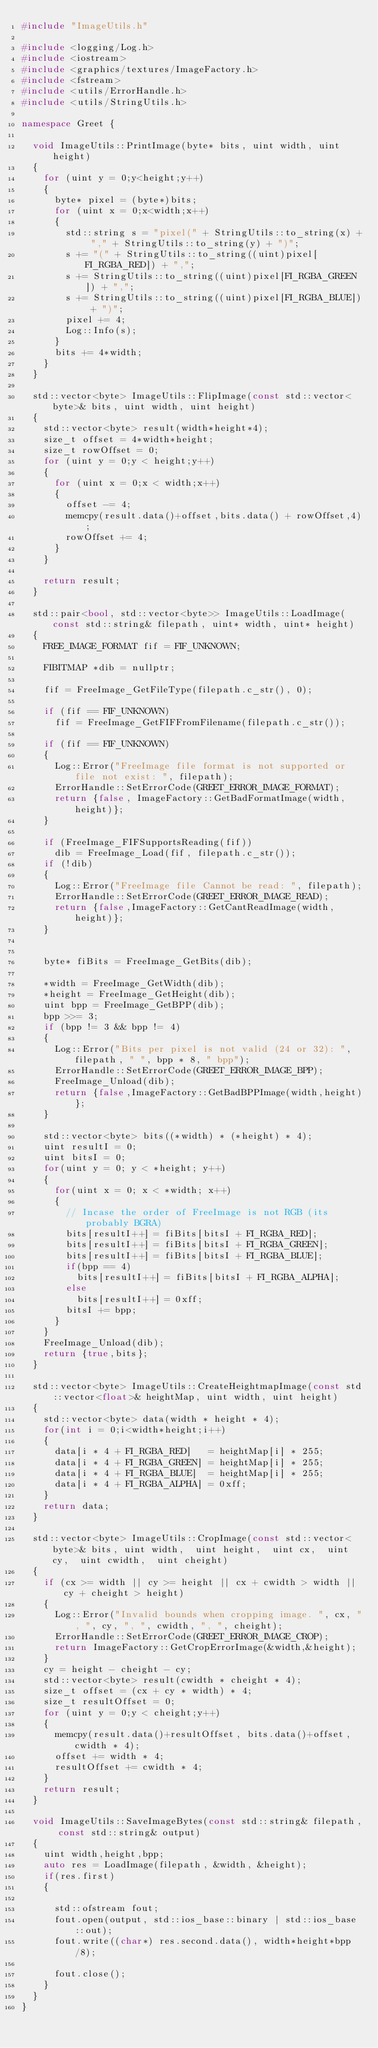<code> <loc_0><loc_0><loc_500><loc_500><_C++_>#include "ImageUtils.h"

#include <logging/Log.h>
#include <iostream>
#include <graphics/textures/ImageFactory.h>
#include <fstream>
#include <utils/ErrorHandle.h>
#include <utils/StringUtils.h>

namespace Greet {

  void ImageUtils::PrintImage(byte* bits, uint width, uint height)
  {
    for (uint y = 0;y<height;y++)
    {
      byte* pixel = (byte*)bits;
      for (uint x = 0;x<width;x++)
      {
        std::string s = "pixel(" + StringUtils::to_string(x) + "," + StringUtils::to_string(y) + ")";
        s += "(" + StringUtils::to_string((uint)pixel[FI_RGBA_RED]) + ",";
        s += StringUtils::to_string((uint)pixel[FI_RGBA_GREEN]) + ",";
        s += StringUtils::to_string((uint)pixel[FI_RGBA_BLUE]) + ")";
        pixel += 4;
        Log::Info(s);
      }
      bits += 4*width;
    }
  }

  std::vector<byte> ImageUtils::FlipImage(const std::vector<byte>& bits, uint width, uint height)
  {
    std::vector<byte> result(width*height*4);
    size_t offset = 4*width*height;
    size_t rowOffset = 0;
    for (uint y = 0;y < height;y++)
    {
      for (uint x = 0;x < width;x++)
      {
        offset -= 4;
        memcpy(result.data()+offset,bits.data() + rowOffset,4);
        rowOffset += 4;
      }
    }

    return result;
  }

  std::pair<bool, std::vector<byte>> ImageUtils::LoadImage(const std::string& filepath, uint* width, uint* height)
  {
    FREE_IMAGE_FORMAT fif = FIF_UNKNOWN;

    FIBITMAP *dib = nullptr;

    fif = FreeImage_GetFileType(filepath.c_str(), 0);

    if (fif == FIF_UNKNOWN)
      fif = FreeImage_GetFIFFromFilename(filepath.c_str());

    if (fif == FIF_UNKNOWN)
    {
      Log::Error("FreeImage file format is not supported or file not exist: ", filepath);
      ErrorHandle::SetErrorCode(GREET_ERROR_IMAGE_FORMAT);
      return {false, ImageFactory::GetBadFormatImage(width,height)};
    }

    if (FreeImage_FIFSupportsReading(fif))
      dib = FreeImage_Load(fif, filepath.c_str());
    if (!dib)
    {
      Log::Error("FreeImage file Cannot be read: ", filepath);
      ErrorHandle::SetErrorCode(GREET_ERROR_IMAGE_READ);
      return {false,ImageFactory::GetCantReadImage(width,height)};
    }


    byte* fiBits = FreeImage_GetBits(dib);

    *width = FreeImage_GetWidth(dib);
    *height = FreeImage_GetHeight(dib);
    uint bpp = FreeImage_GetBPP(dib);
    bpp >>= 3;
    if (bpp != 3 && bpp != 4)
    {
      Log::Error("Bits per pixel is not valid (24 or 32): ", filepath, " ", bpp * 8, " bpp");
      ErrorHandle::SetErrorCode(GREET_ERROR_IMAGE_BPP);
      FreeImage_Unload(dib);
      return {false,ImageFactory::GetBadBPPImage(width,height)};
    }

    std::vector<byte> bits((*width) * (*height) * 4);
    uint resultI = 0;
    uint bitsI = 0;
    for(uint y = 0; y < *height; y++)
    {
      for(uint x = 0; x < *width; x++)
      {
        // Incase the order of FreeImage is not RGB (its probably BGRA)
        bits[resultI++] = fiBits[bitsI + FI_RGBA_RED];
        bits[resultI++] = fiBits[bitsI + FI_RGBA_GREEN];
        bits[resultI++] = fiBits[bitsI + FI_RGBA_BLUE];
        if(bpp == 4)
          bits[resultI++] = fiBits[bitsI + FI_RGBA_ALPHA];
        else
          bits[resultI++] = 0xff;
        bitsI += bpp;
      }
    }
    FreeImage_Unload(dib);
    return {true,bits};
  }

  std::vector<byte> ImageUtils::CreateHeightmapImage(const std::vector<float>& heightMap, uint width, uint height)
  {
    std::vector<byte> data(width * height * 4);
    for(int i = 0;i<width*height;i++)
    {
      data[i * 4 + FI_RGBA_RED]   = heightMap[i] * 255;
      data[i * 4 + FI_RGBA_GREEN] = heightMap[i] * 255;
      data[i * 4 + FI_RGBA_BLUE]  = heightMap[i] * 255;
      data[i * 4 + FI_RGBA_ALPHA] = 0xff;
    }
    return data;
  }

  std::vector<byte> ImageUtils::CropImage(const std::vector<byte>& bits, uint width,  uint height,  uint cx,  uint cy,  uint cwidth,  uint cheight)
  {
    if (cx >= width || cy >= height || cx + cwidth > width || cy + cheight > height)
    {
      Log::Error("Invalid bounds when cropping image. ", cx, ", ", cy, ", ", cwidth, ", ", cheight);
      ErrorHandle::SetErrorCode(GREET_ERROR_IMAGE_CROP);
      return ImageFactory::GetCropErrorImage(&width,&height);
    }
    cy = height - cheight - cy;
    std::vector<byte> result(cwidth * cheight * 4);
    size_t offset = (cx + cy * width) * 4;
    size_t resultOffset = 0;
    for (uint y = 0;y < cheight;y++)
    {
      memcpy(result.data()+resultOffset, bits.data()+offset, cwidth * 4);
      offset += width * 4;
      resultOffset += cwidth * 4;
    }
    return result;
  }

  void ImageUtils::SaveImageBytes(const std::string& filepath, const std::string& output)
  {
    uint width,height,bpp;
    auto res = LoadImage(filepath, &width, &height);
    if(res.first)
    {

      std::ofstream fout;
      fout.open(output, std::ios_base::binary | std::ios_base::out);
      fout.write((char*) res.second.data(), width*height*bpp/8);

      fout.close();
    }
  }
}
</code> 